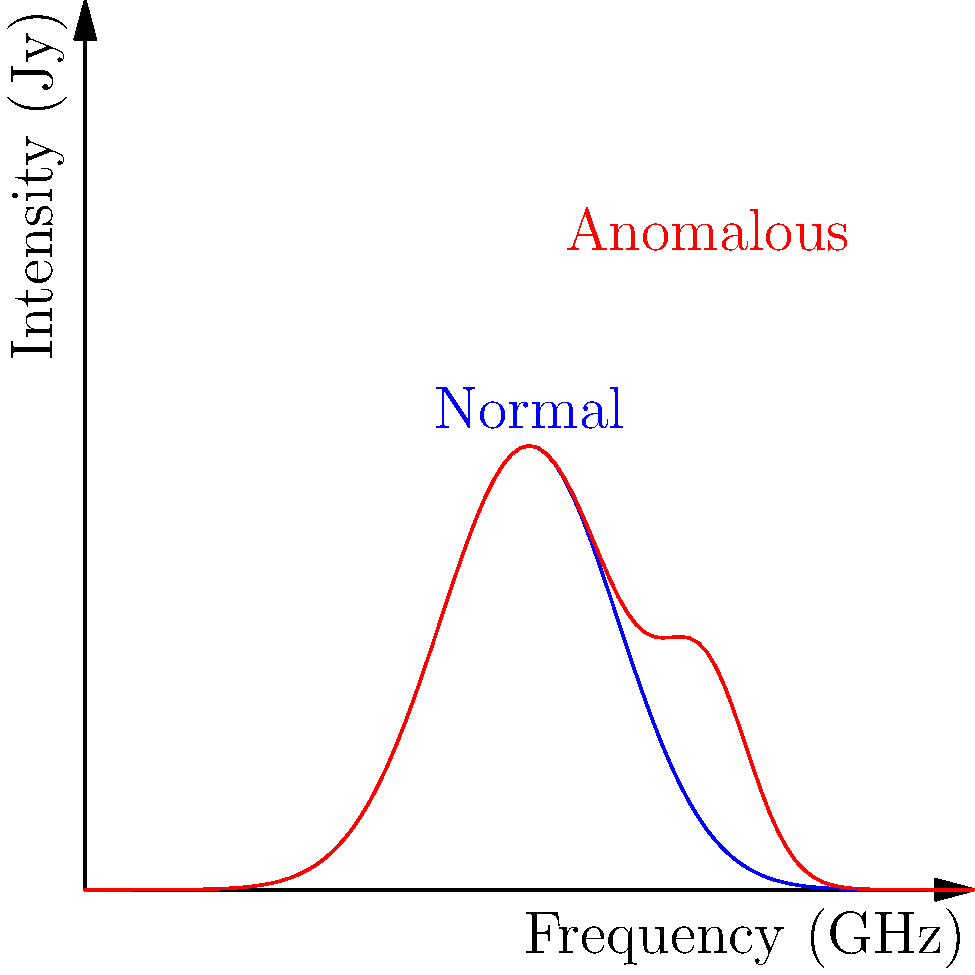In the context of using convolutional neural networks (CNNs) to identify anomalous celestial objects from radio telescope imagery, consider the spectral profiles shown in the graph. The blue curve represents a typical celestial object, while the red curve shows an object with an unusual spectral feature. What key characteristic of CNNs would be most crucial in distinguishing between these two types of objects, and why? To answer this question, let's consider the key characteristics of CNNs and how they relate to the problem at hand:

1. Convolutional layers: CNNs use convolutional filters to detect local patterns in the input data. In this case, these layers would be crucial for identifying the spectral features that differentiate the normal and anomalous objects.

2. Pooling layers: These layers reduce the spatial dimensions of the data, helping to extract the most salient features. For spectral data, pooling could help identify the most significant peaks or variations in the spectrum.

3. Non-linearity: Activation functions like ReLU introduce non-linearity, allowing the network to learn complex, non-linear relationships in the data. This is important for capturing the subtle differences in spectral shapes.

4. Hierarchical feature learning: CNNs learn features at multiple levels of abstraction. This could help in identifying both low-level spectral features and higher-level patterns across the entire spectrum.

5. Translation invariance: CNNs can detect features regardless of their position in the input. This is particularly useful for identifying spectral features that may occur at different frequencies for different objects.

6. Parameter sharing: Convolutional layers use the same set of filters across the entire input, which is efficient and helps in detecting similar features at different locations.

Considering the spectral profiles shown, the most crucial characteristic would be the convolutional layers. Here's why:

1. The key difference between the normal and anomalous spectra is the additional peak in the red curve.
2. Convolutional layers are specifically designed to detect local patterns and features, such as peaks or unusual shapes in spectral data.
3. By applying various filters, the CNN can learn to identify the presence or absence of additional spectral features that distinguish anomalous objects.
4. The ability to detect these localized features is essential for differentiating between normal and anomalous celestial objects based on their spectral profiles.

While other characteristics of CNNs are also important, the convolutional layers provide the fundamental ability to detect and differentiate the spectral features that are key to identifying anomalous objects in this context.
Answer: Convolutional layers 